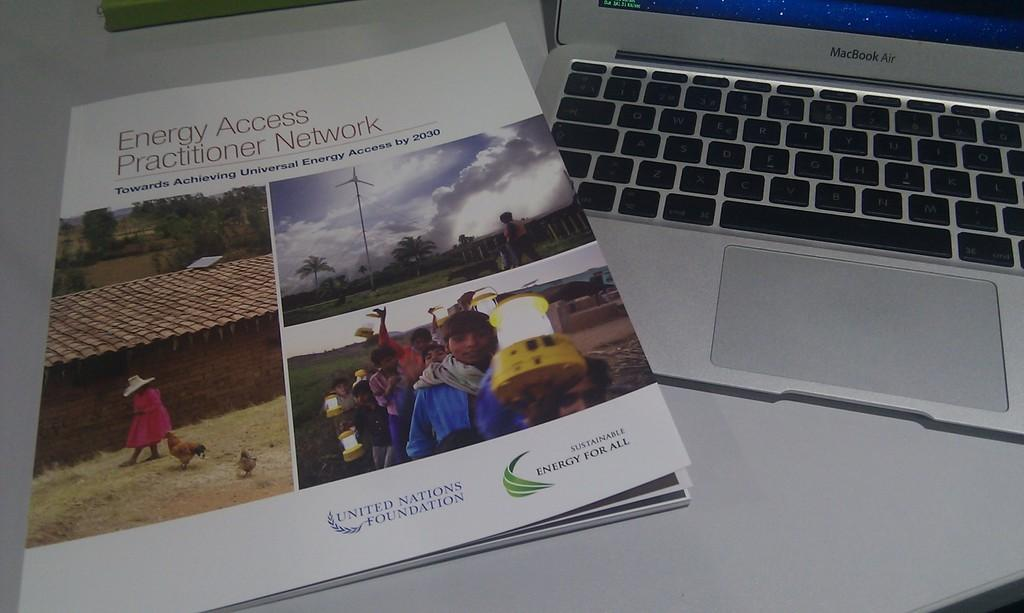Provide a one-sentence caption for the provided image. An copy of the Energy Access Practitioner Network is placed on top of a lap top. 